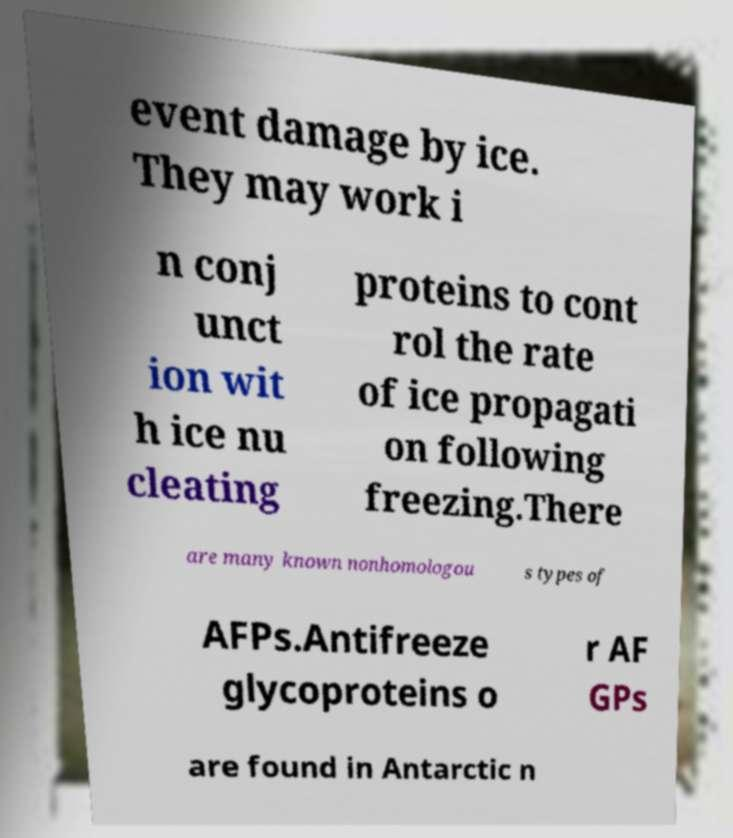Could you assist in decoding the text presented in this image and type it out clearly? event damage by ice. They may work i n conj unct ion wit h ice nu cleating proteins to cont rol the rate of ice propagati on following freezing.There are many known nonhomologou s types of AFPs.Antifreeze glycoproteins o r AF GPs are found in Antarctic n 